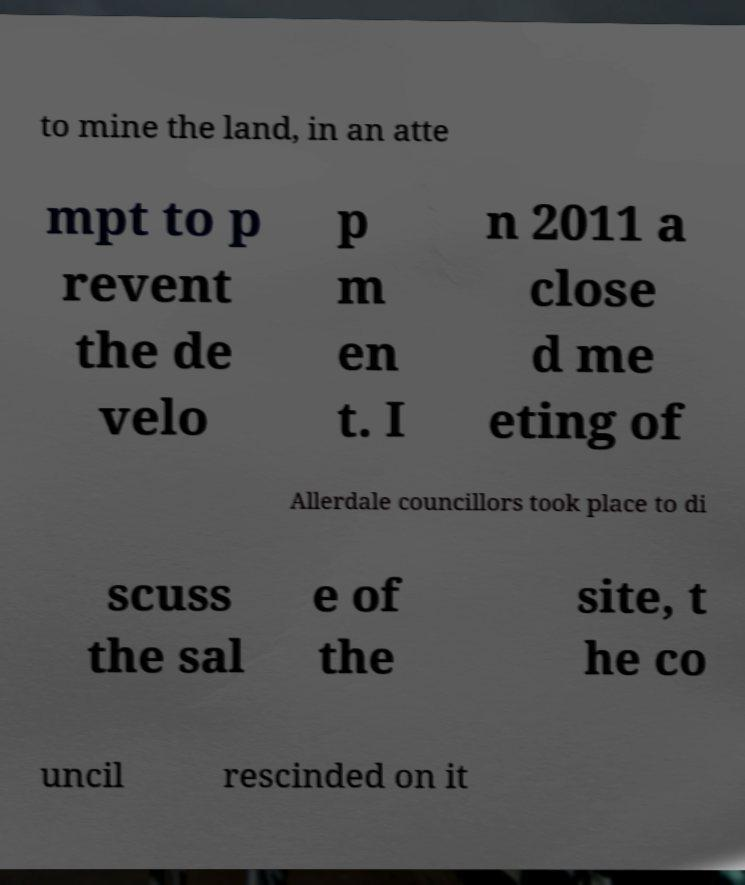Could you assist in decoding the text presented in this image and type it out clearly? to mine the land, in an atte mpt to p revent the de velo p m en t. I n 2011 a close d me eting of Allerdale councillors took place to di scuss the sal e of the site, t he co uncil rescinded on it 